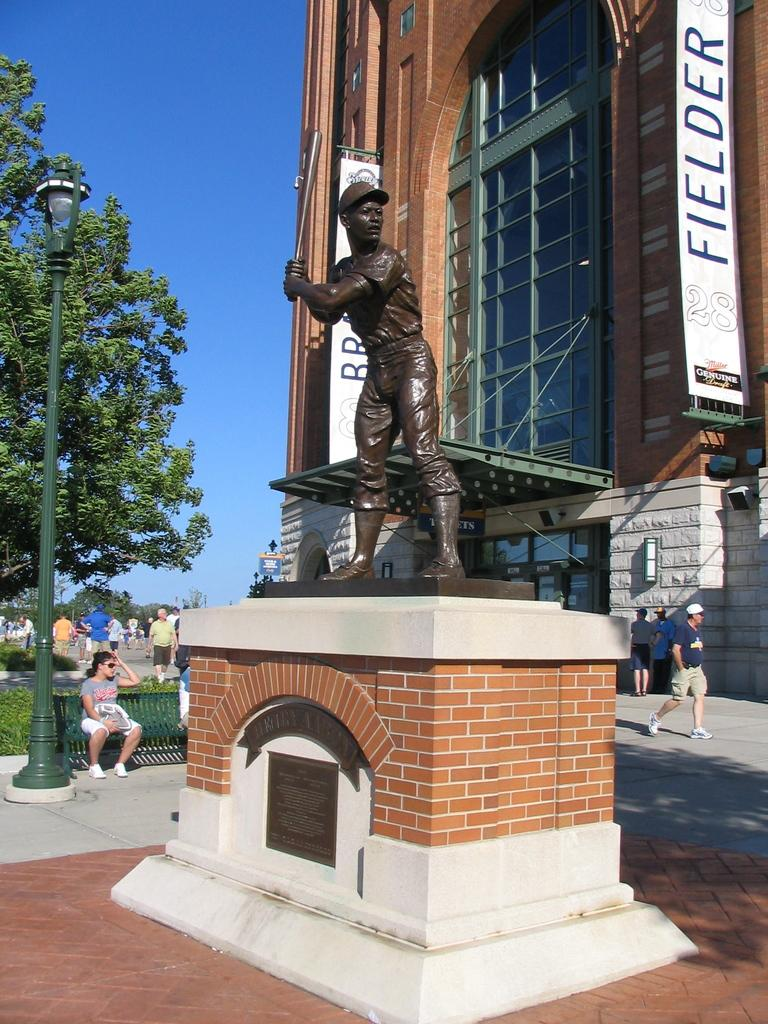<image>
Provide a brief description of the given image. A statue of a baseball player stands in front of the stadium where the Brewers play. 